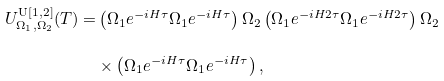Convert formula to latex. <formula><loc_0><loc_0><loc_500><loc_500>U _ { \Omega _ { 1 } , \Omega _ { 2 } } ^ { \text {U} [ 1 , 2 ] } ( T ) = & \left ( \Omega _ { 1 } e ^ { - i H \tau } \Omega _ { 1 } e ^ { - i H \tau } \right ) \Omega _ { 2 } \left ( \Omega _ { 1 } e ^ { - i H 2 \tau } \Omega _ { 1 } e ^ { - i H 2 \tau } \right ) \Omega _ { 2 } \\ & \times \left ( \Omega _ { 1 } e ^ { - i H \tau } \Omega _ { 1 } e ^ { - i H \tau } \right ) ,</formula> 